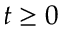Convert formula to latex. <formula><loc_0><loc_0><loc_500><loc_500>t \geq 0</formula> 